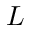<formula> <loc_0><loc_0><loc_500><loc_500>L</formula> 